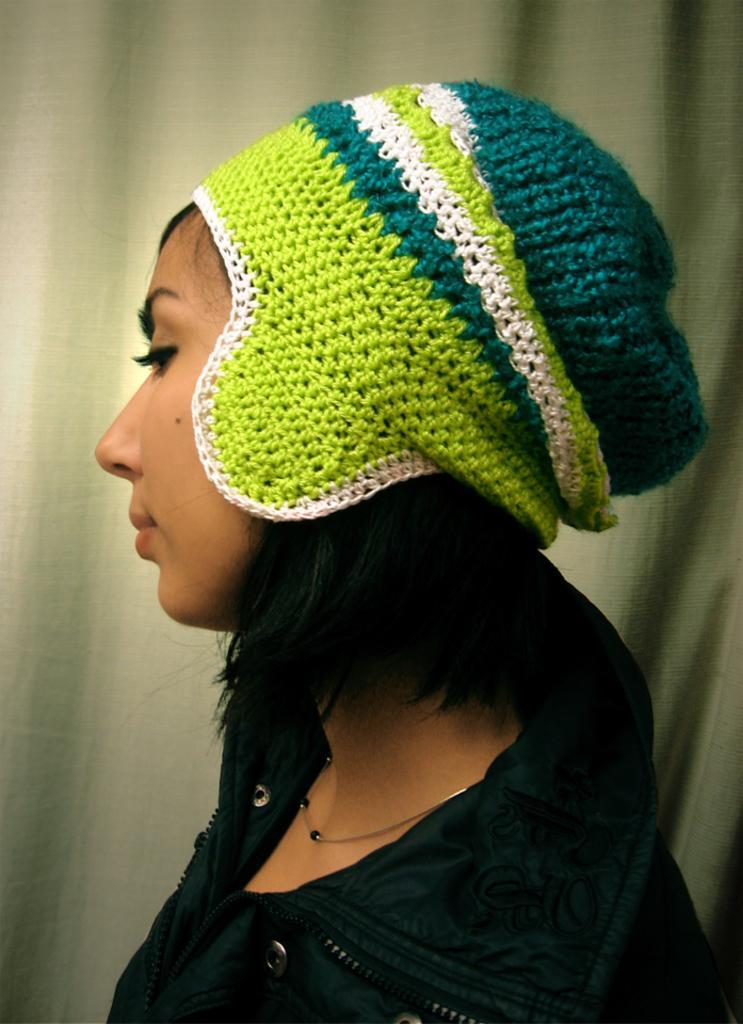Can you describe this image briefly? In this picture I can see a woman wore a cap on her head and she wore a black color coat and I can see a curtain on the background. 